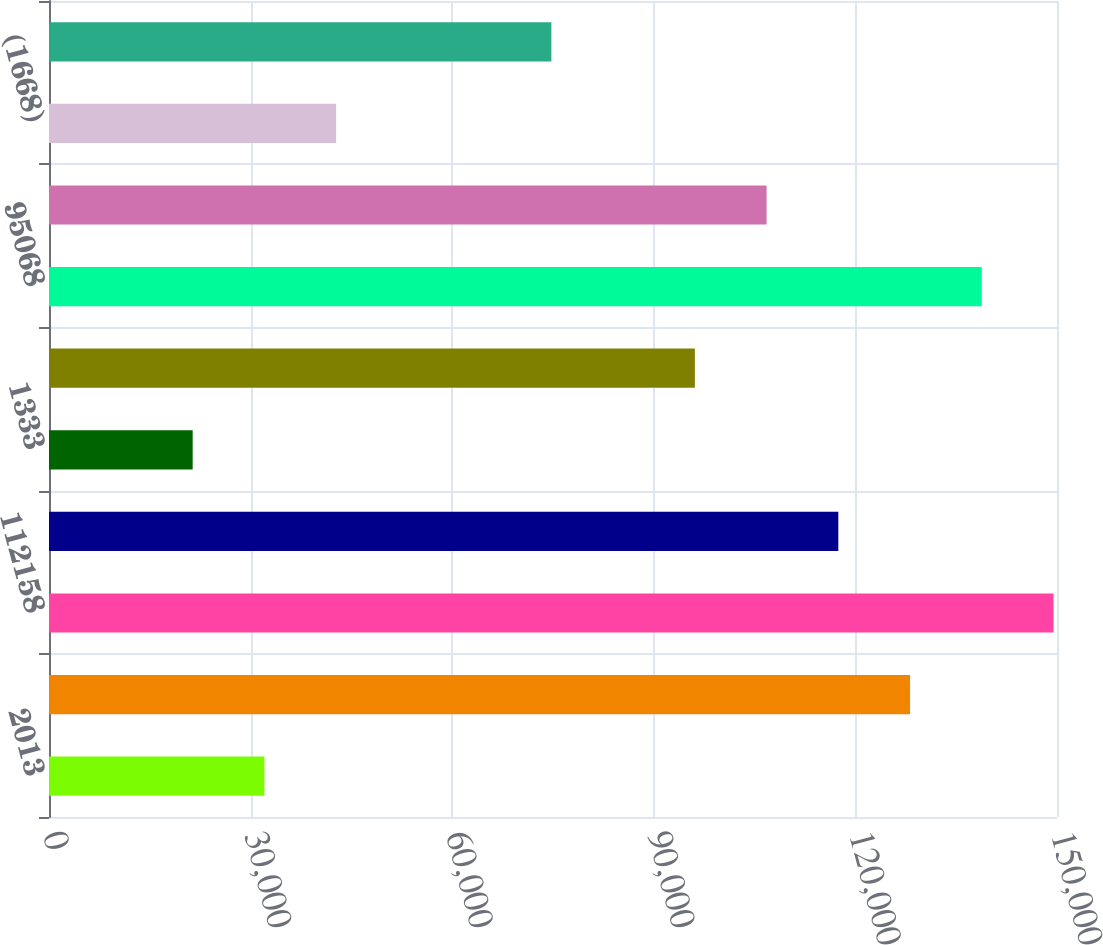Convert chart to OTSL. <chart><loc_0><loc_0><loc_500><loc_500><bar_chart><fcel>2013<fcel>71951<fcel>112158<fcel>57962<fcel>1333<fcel>16105<fcel>95068<fcel>17090<fcel>(1668)<fcel>15422<nl><fcel>32055.2<fcel>128134<fcel>149485<fcel>117458<fcel>21379.8<fcel>96107.6<fcel>138809<fcel>106783<fcel>42730.6<fcel>74756.8<nl></chart> 